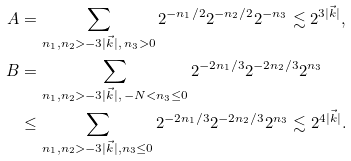Convert formula to latex. <formula><loc_0><loc_0><loc_500><loc_500>A & = \sum _ { n _ { 1 } , n _ { 2 } > - 3 | \vec { k } | , \, n _ { 3 } > 0 } 2 ^ { - n _ { 1 } / 2 } 2 ^ { - n _ { 2 } / 2 } 2 ^ { - n _ { 3 } } \lesssim 2 ^ { 3 | \vec { k } | } , \\ B & = \sum _ { n _ { 1 } , n _ { 2 } > - 3 | \vec { k } | , \, - N < n _ { 3 } \leq 0 } 2 ^ { - 2 n _ { 1 } / 3 } 2 ^ { - 2 n _ { 2 } / 3 } 2 ^ { n _ { 3 } } \\ & \leq \sum _ { n _ { 1 } , n _ { 2 } > - 3 | \vec { k } | , n _ { 3 } \leq 0 } 2 ^ { - 2 n _ { 1 } / 3 } 2 ^ { - 2 n _ { 2 } / 3 } 2 ^ { n _ { 3 } } \lesssim 2 ^ { 4 | \vec { k } | } .</formula> 